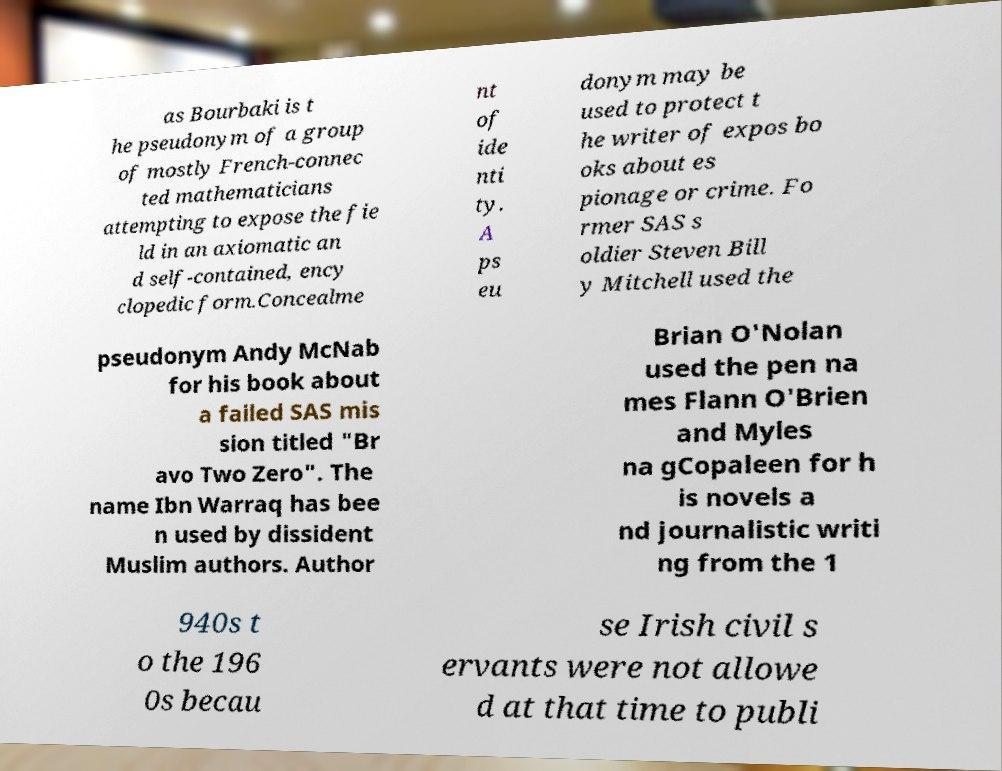I need the written content from this picture converted into text. Can you do that? as Bourbaki is t he pseudonym of a group of mostly French-connec ted mathematicians attempting to expose the fie ld in an axiomatic an d self-contained, ency clopedic form.Concealme nt of ide nti ty. A ps eu donym may be used to protect t he writer of expos bo oks about es pionage or crime. Fo rmer SAS s oldier Steven Bill y Mitchell used the pseudonym Andy McNab for his book about a failed SAS mis sion titled "Br avo Two Zero". The name Ibn Warraq has bee n used by dissident Muslim authors. Author Brian O'Nolan used the pen na mes Flann O'Brien and Myles na gCopaleen for h is novels a nd journalistic writi ng from the 1 940s t o the 196 0s becau se Irish civil s ervants were not allowe d at that time to publi 